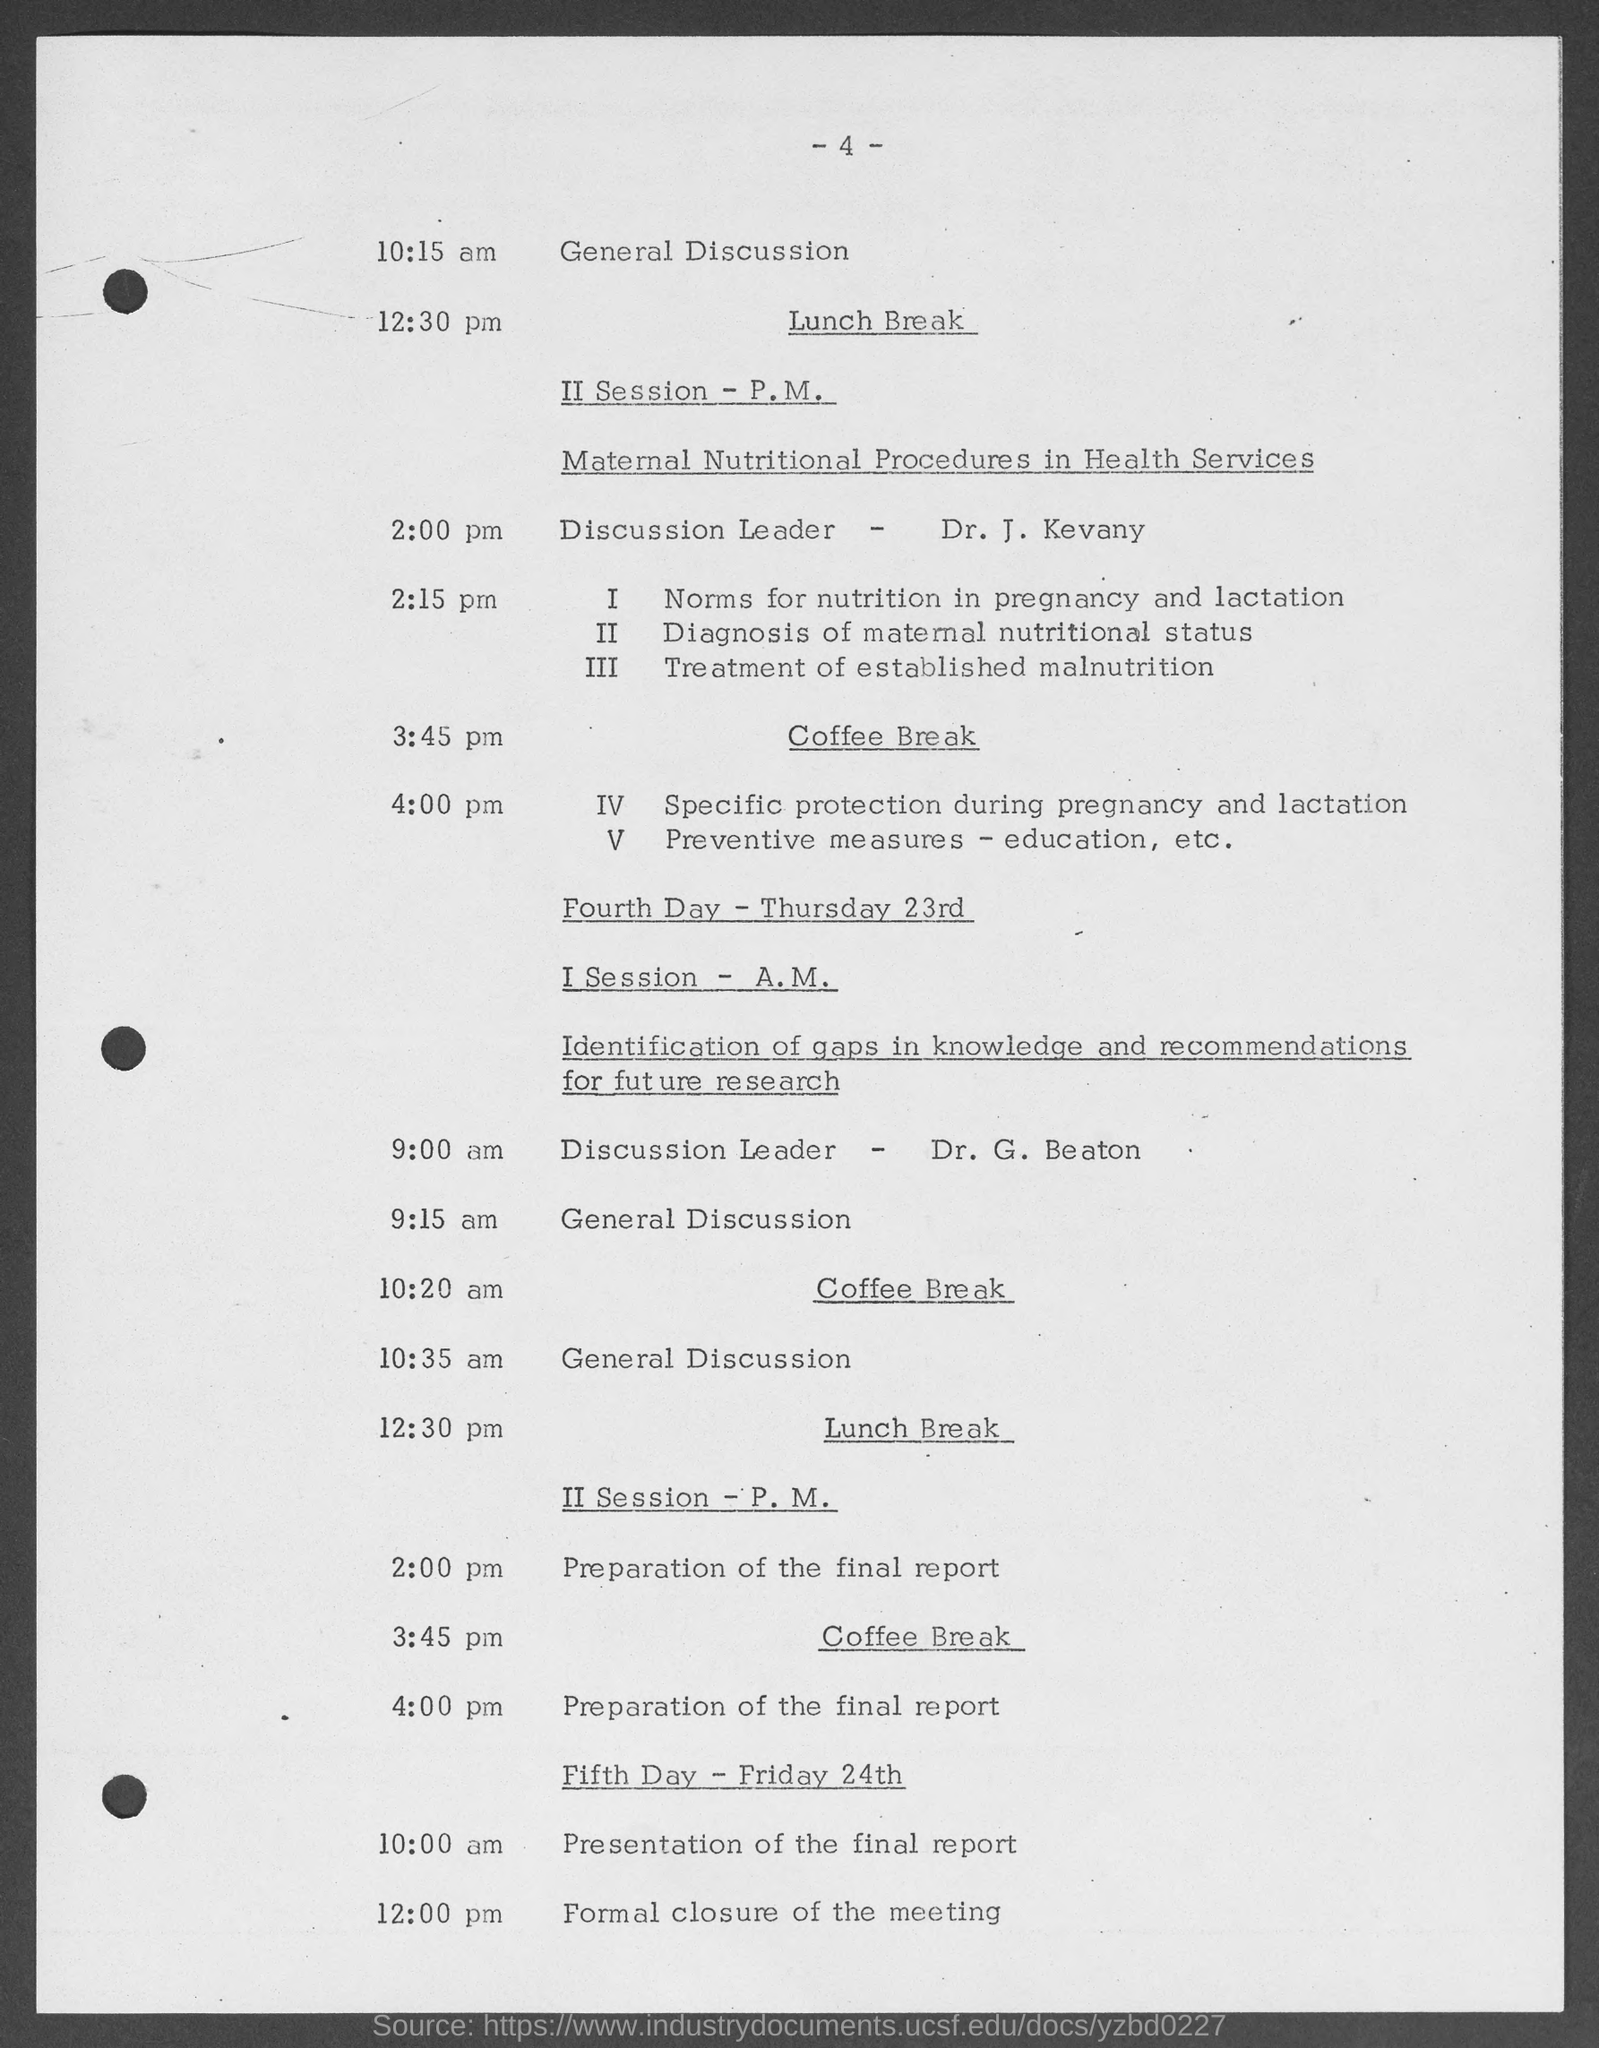What is the page number?
Keep it short and to the point. - 4 -. What is the event at 10:15 am?
Ensure brevity in your answer.  General discussion. What is the II Session - P.M. about?
Ensure brevity in your answer.  Maternal nutritional procedures in health services. Who is the discussion leader for II Session - P.M.?
Provide a short and direct response. Dr. j. kevany. On fourth day, I Session - A.M. who is the discussion leader?
Your answer should be very brief. Dr. G. Beaton. On fourth day, what is the topic of I Session - A.M.?
Provide a short and direct response. Identification of gaps in knowledge and recommendations for future research. At what time is the formal closure of the meeting scheduled?
Keep it short and to the point. 12:00 pm. 